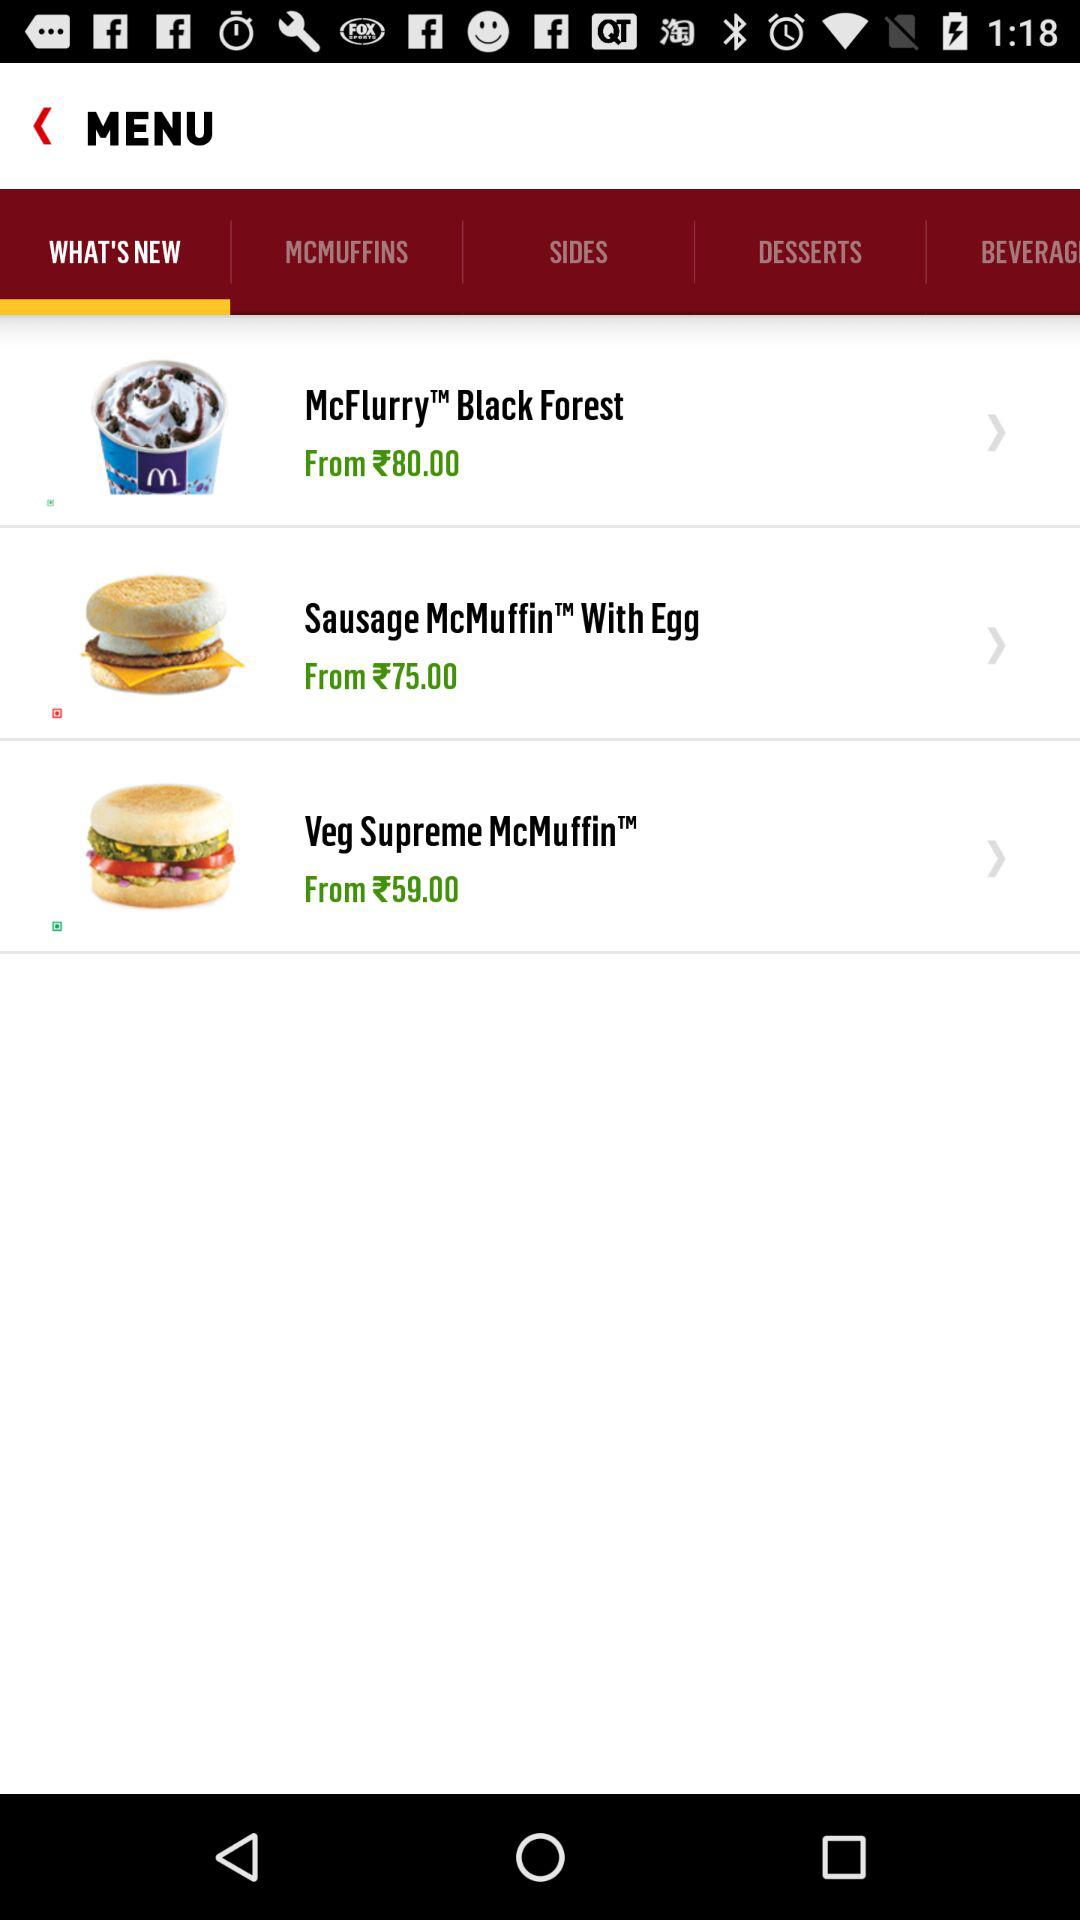Which burgers are shown in the menu? The burgers shown in the menu are "Sausage McMuffin With Egg" and "Veg Supreme McMuffin". 